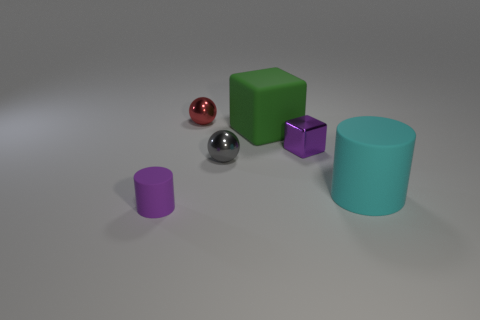Add 3 brown cylinders. How many objects exist? 9 Subtract all red balls. How many balls are left? 1 Subtract all purple cylinders. How many cyan balls are left? 0 Subtract 0 brown cylinders. How many objects are left? 6 Subtract all gray cylinders. Subtract all cyan blocks. How many cylinders are left? 2 Subtract all large cyan objects. Subtract all purple rubber cylinders. How many objects are left? 4 Add 1 purple metallic things. How many purple metallic things are left? 2 Add 5 tiny red shiny things. How many tiny red shiny things exist? 6 